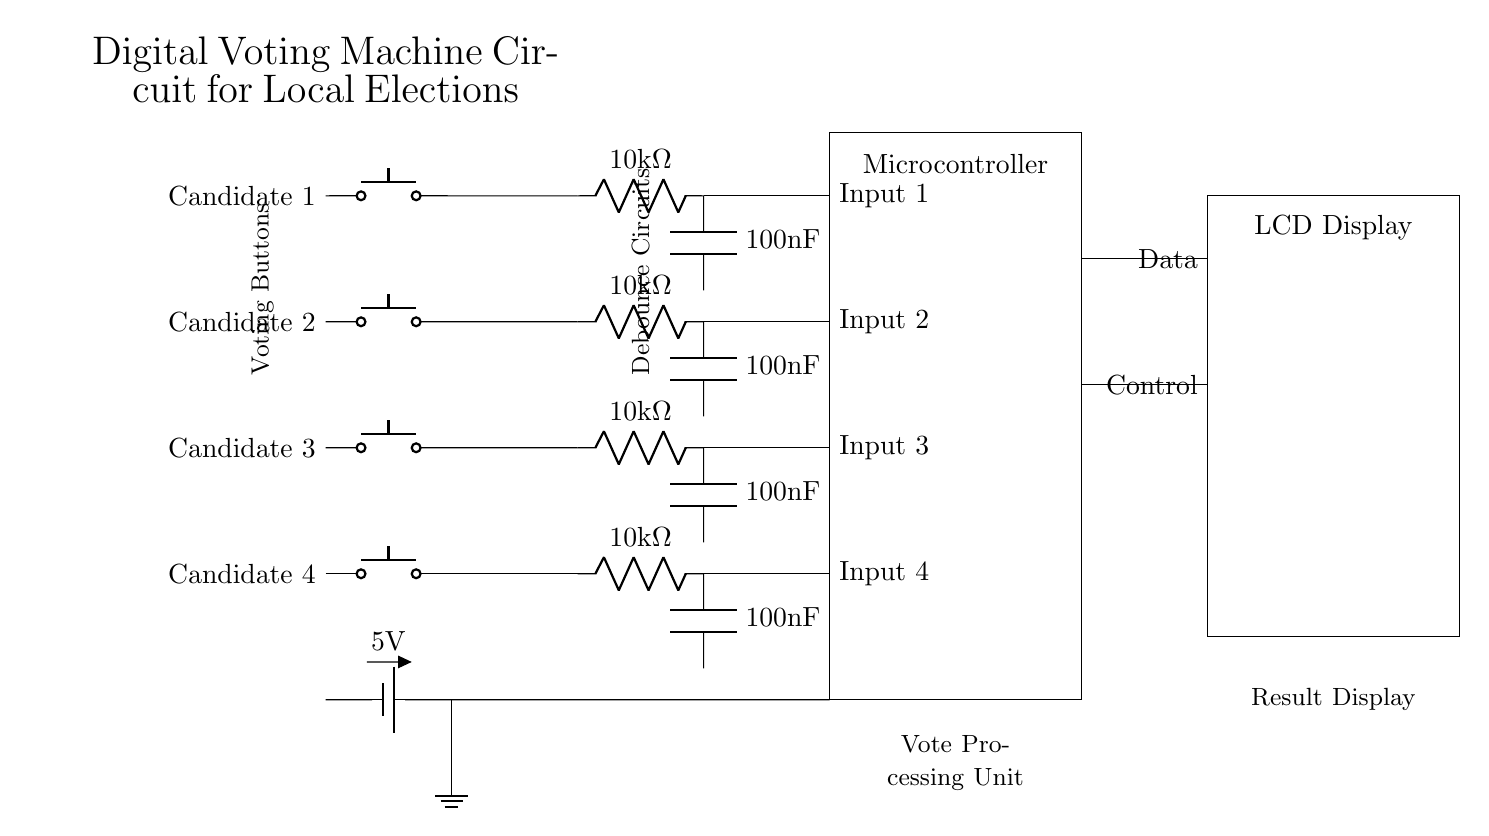What is the supply voltage of the circuit? The supply voltage is indicated by the battery symbol, which displays a value of 5 volts. This is the voltage that powers the entire circuit.
Answer: 5 volts What component represents the voting options for candidates? The voting options are represented by four push buttons, each corresponding to a candidate, labeled as Candidate 1, Candidate 2, Candidate 3, and Candidate 4.
Answer: Push buttons How many candidates can be selected in this voting machine? The circuit diagram shows four distinct push buttons for four candidates, indicating that the machine can handle votes for four different candidates.
Answer: Four What is the purpose of the resistors in the debounce circuits? The resistors in the debounce circuits are used to stabilize the input signals coming from the push buttons. This helps to prevent false triggering due to mechanical bouncing when the button is pressed.
Answer: Stabilization of input signals What is the function of the microcontroller in this circuit? The microcontroller processes the input from the push buttons, interprets the votes, and communicates the results to the LCD display in a controlled manner.
Answer: Vote processing and control What type of display is used to show the results? The circuit uses an LCD display to show the voting results and any other relevant information related to the voting process.
Answer: LCD display How is the power supply connected in the circuit? The power supply is connected through a battery at the beginning of the circuit, supplying 5 volts and grounding is established at the appropriate point, ensuring the whole circuit operates efficiently.
Answer: Through a battery 